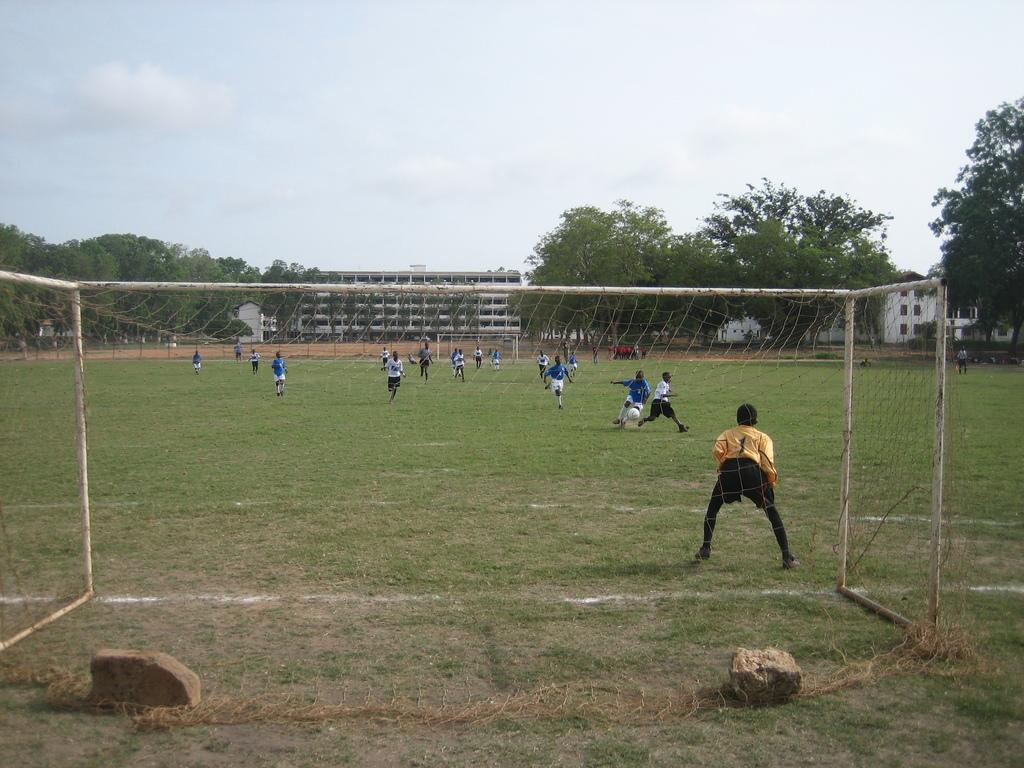What is happening on the ground in the image? There are players on the ground in the image. What is the purpose of the net in the image? The net is likely used for separating the playing area or for a game being played. What type of structures can be seen in the image? There are buildings visible in the image. What type of vegetation is present in the image? There are trees in the image. What type of natural elements can be seen on the ground in the image? There are stones in the image. What is visible at the top of the image? The sky is visible at the top of the image. What type of bean is being used as a prop in the image? There is no bean present in the image. What type of drum can be heard playing in the background of the image? There is no drum or sound present in the image. 